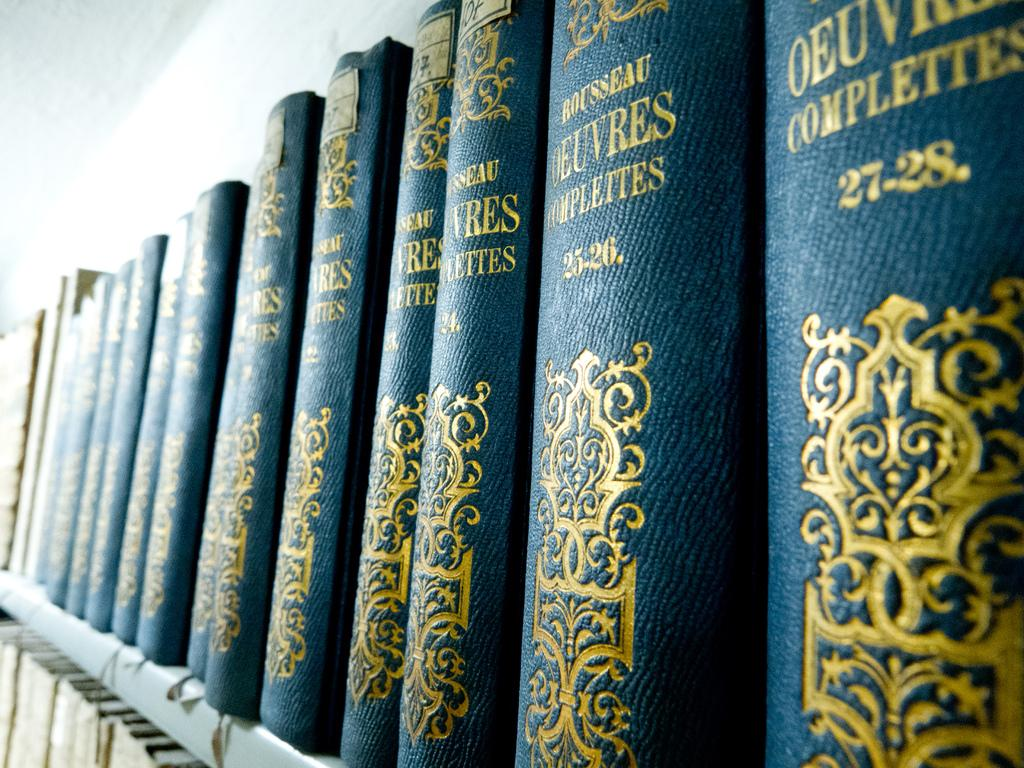<image>
Share a concise interpretation of the image provided. Several side pictures of book spines reading ROUSSEAU OEUVRES COMPLEITES. 